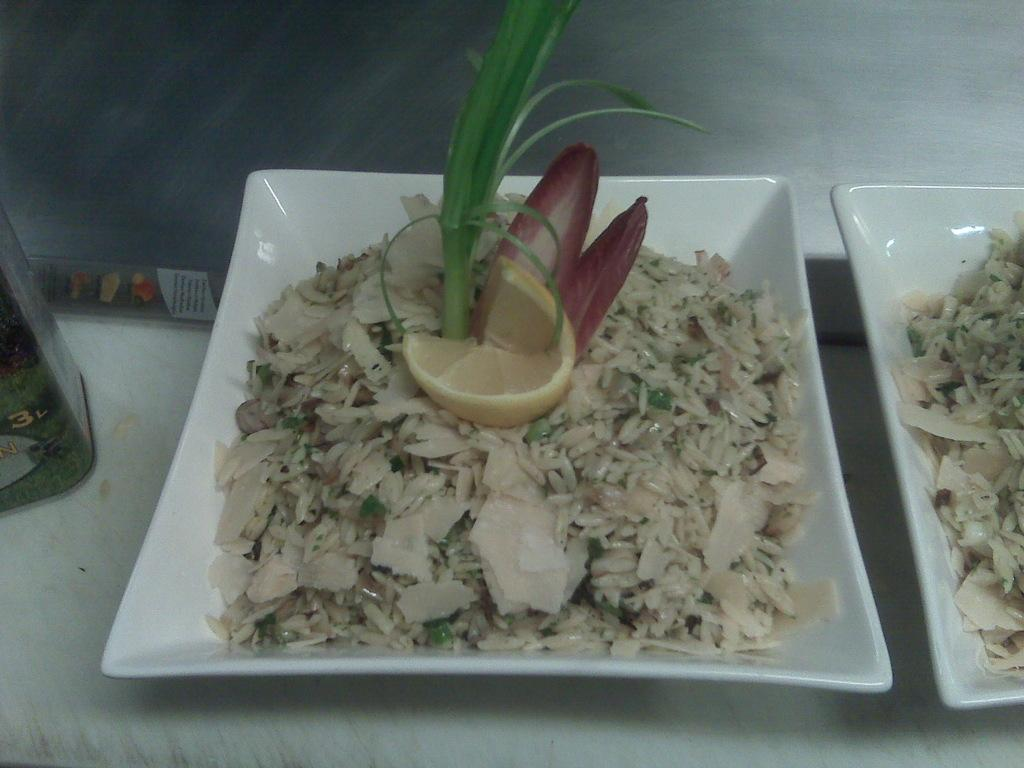What is the main object in the center of the image? There is a plate in the center of the image. What is on the plate in the image? The plate contains rice and other food items. Are there any other plates visible in the image? Yes, there is another plate on the right side of the image. What type of cheese can be seen on the plate in the image? There is no cheese present on the plate in the image; it contains rice and other food items. Is there a pipe visible in the image? There is no pipe present in the image. 